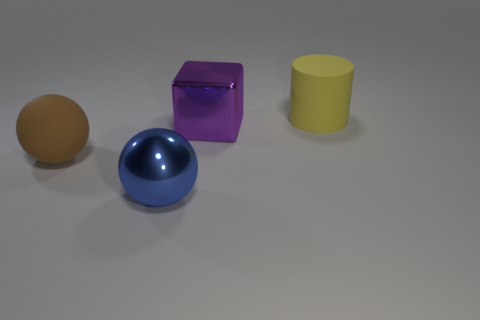Add 1 metal spheres. How many objects exist? 5 Subtract all cylinders. How many objects are left? 3 Add 1 big blue metal balls. How many big blue metal balls are left? 2 Add 4 large cyan matte cubes. How many large cyan matte cubes exist? 4 Subtract 0 green balls. How many objects are left? 4 Subtract all large purple things. Subtract all blue matte cubes. How many objects are left? 3 